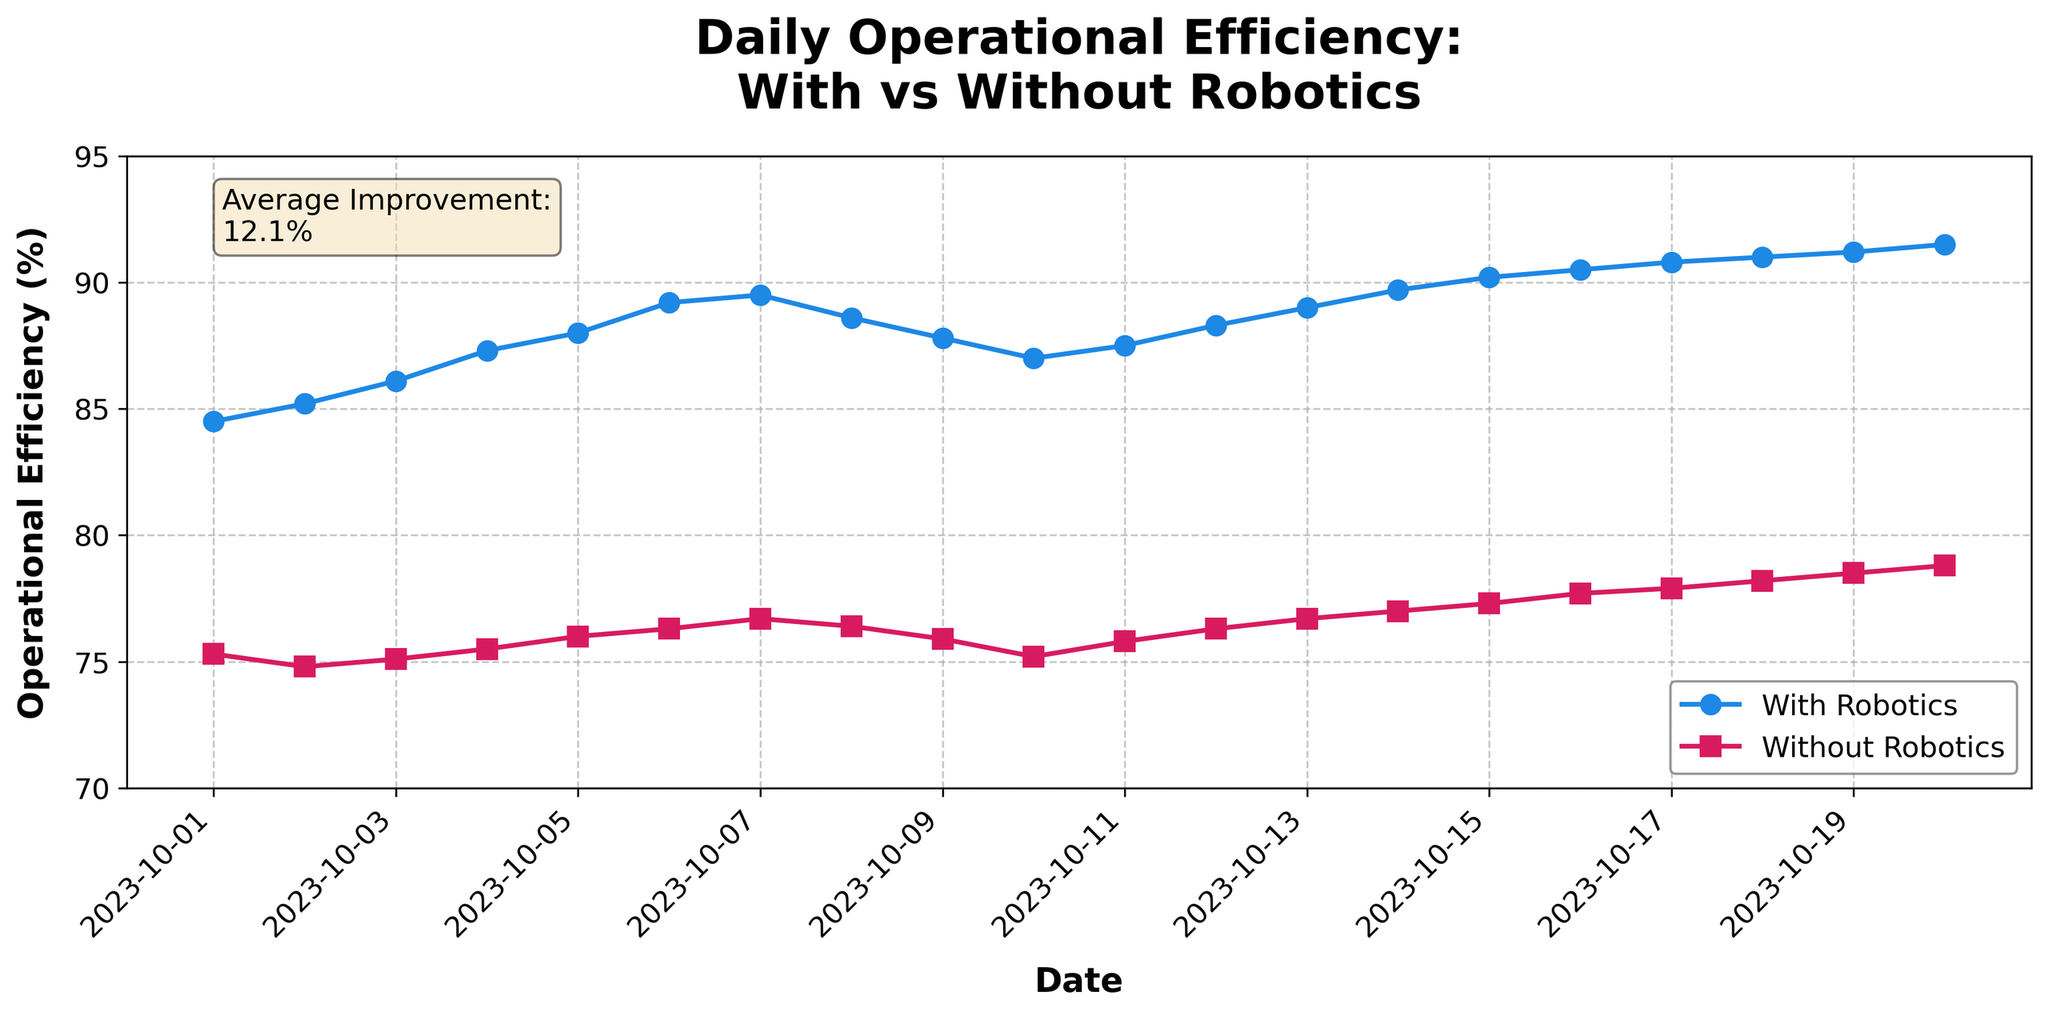What is the title of the plot? The title of the plot is displayed at the top. You can read it directly from the figure.
Answer: Daily Operational Efficiency: With vs Without Robotics How many days are represented in the plot? Count the number of data points along the x-axis, each representing one day.
Answer: 20 What are the colors and markers used to represent 'With Robotics' and 'Without Robotics'? Identify the line colors and markers in the plot legend. 'With Robotics' is shown in blue with circles, and 'Without Robotics' is in red with squares.
Answer: Blue circles for 'With Robotics', Red squares for 'Without Robotics' On which date did 'Operational Efficiency With Robotics' reach its highest value? Look for the peak point on the 'With Robotics' line and note the corresponding date on the x-axis.
Answer: 2023-10-20 What is the average improvement in operational efficiency when using robotics, according to the text box on the plot? Read the text box on the plot that highlights the average improvement.
Answer: 12.2% What was the operational efficiency without robotics on 2023-10-10? Find the point on the 'Without Robotics' line for the given date and read the corresponding y-value.
Answer: 75.2% By how much did the operational efficiency improve from 2023-10-01 to 2023-10-20 when using robotics? Subtract the operational efficiency value on 2023-10-01 from the value on 2023-10-20 for 'With Robotics'.
Answer: 7.0% What was the difference in operational efficiency between 'With Robotics' and 'Without Robotics' on 2023-10-05? Find both y-values for the given date and calculate the difference.
Answer: 12.0% On which date was the gap in operational efficiency between 'With Robotics' and 'Without Robotics' smallest? Compare the gaps between the two lines for each date to find the smallest one.
Answer: 2023-10-07 Describe the overall trend of operational efficiency with and without robotics over time. Observe both lines and note the general direction and changes over the dates. 'With Robotics' shows a more consistent and rising trend, while 'Without Robotics' shows a slower and steadier increase.
Answer: 'With Robotics' rises consistently, 'Without Robotics' rises slowly and steadily 